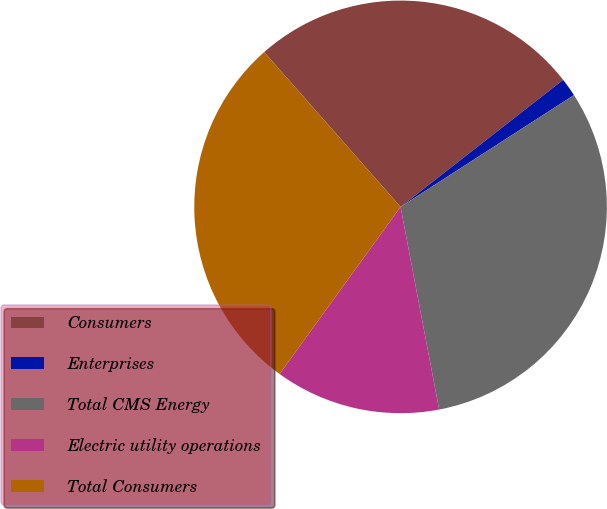Convert chart. <chart><loc_0><loc_0><loc_500><loc_500><pie_chart><fcel>Consumers<fcel>Enterprises<fcel>Total CMS Energy<fcel>Electric utility operations<fcel>Total Consumers<nl><fcel>25.94%<fcel>1.44%<fcel>31.12%<fcel>12.97%<fcel>28.53%<nl></chart> 